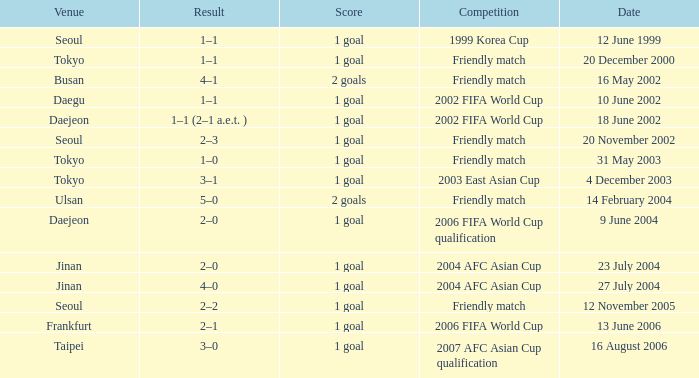What is the venue of the game on 20 November 2002? Seoul. 